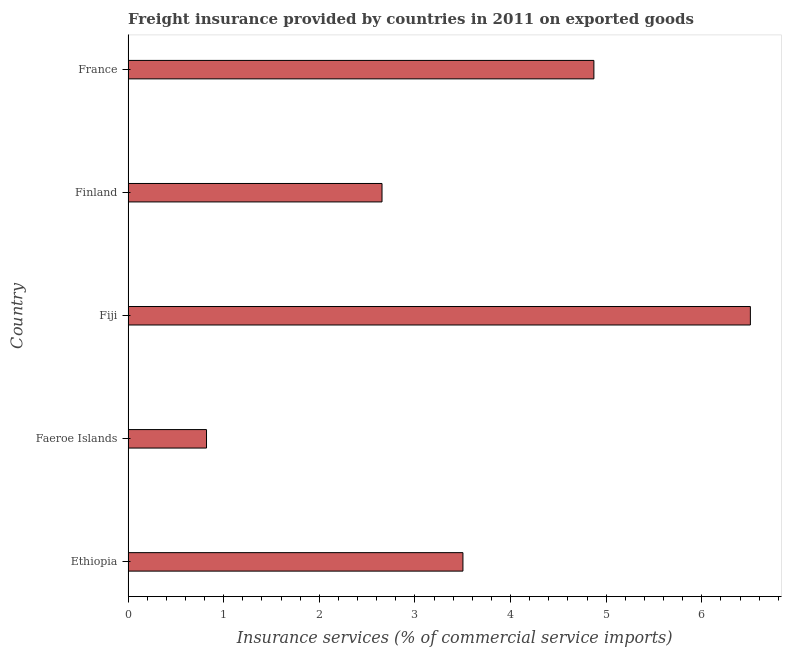Does the graph contain grids?
Your response must be concise. No. What is the title of the graph?
Make the answer very short. Freight insurance provided by countries in 2011 on exported goods . What is the label or title of the X-axis?
Offer a very short reply. Insurance services (% of commercial service imports). What is the label or title of the Y-axis?
Your response must be concise. Country. What is the freight insurance in Faeroe Islands?
Your answer should be very brief. 0.82. Across all countries, what is the maximum freight insurance?
Provide a short and direct response. 6.51. Across all countries, what is the minimum freight insurance?
Your response must be concise. 0.82. In which country was the freight insurance maximum?
Keep it short and to the point. Fiji. In which country was the freight insurance minimum?
Your answer should be compact. Faeroe Islands. What is the sum of the freight insurance?
Make the answer very short. 18.36. What is the difference between the freight insurance in Faeroe Islands and Fiji?
Provide a short and direct response. -5.69. What is the average freight insurance per country?
Offer a very short reply. 3.67. What is the median freight insurance?
Your answer should be very brief. 3.5. What is the ratio of the freight insurance in Finland to that in France?
Your answer should be very brief. 0.55. Is the freight insurance in Ethiopia less than that in Fiji?
Your answer should be compact. Yes. Is the difference between the freight insurance in Fiji and Finland greater than the difference between any two countries?
Give a very brief answer. No. What is the difference between the highest and the second highest freight insurance?
Your response must be concise. 1.64. Is the sum of the freight insurance in Finland and France greater than the maximum freight insurance across all countries?
Give a very brief answer. Yes. What is the difference between the highest and the lowest freight insurance?
Ensure brevity in your answer.  5.69. Are all the bars in the graph horizontal?
Offer a terse response. Yes. What is the difference between two consecutive major ticks on the X-axis?
Offer a very short reply. 1. What is the Insurance services (% of commercial service imports) in Ethiopia?
Provide a short and direct response. 3.5. What is the Insurance services (% of commercial service imports) of Faeroe Islands?
Ensure brevity in your answer.  0.82. What is the Insurance services (% of commercial service imports) in Fiji?
Offer a terse response. 6.51. What is the Insurance services (% of commercial service imports) in Finland?
Make the answer very short. 2.66. What is the Insurance services (% of commercial service imports) of France?
Your answer should be very brief. 4.87. What is the difference between the Insurance services (% of commercial service imports) in Ethiopia and Faeroe Islands?
Your response must be concise. 2.68. What is the difference between the Insurance services (% of commercial service imports) in Ethiopia and Fiji?
Your response must be concise. -3.01. What is the difference between the Insurance services (% of commercial service imports) in Ethiopia and Finland?
Offer a terse response. 0.85. What is the difference between the Insurance services (% of commercial service imports) in Ethiopia and France?
Your response must be concise. -1.37. What is the difference between the Insurance services (% of commercial service imports) in Faeroe Islands and Fiji?
Give a very brief answer. -5.69. What is the difference between the Insurance services (% of commercial service imports) in Faeroe Islands and Finland?
Give a very brief answer. -1.84. What is the difference between the Insurance services (% of commercial service imports) in Faeroe Islands and France?
Ensure brevity in your answer.  -4.05. What is the difference between the Insurance services (% of commercial service imports) in Fiji and Finland?
Keep it short and to the point. 3.85. What is the difference between the Insurance services (% of commercial service imports) in Fiji and France?
Your answer should be compact. 1.64. What is the difference between the Insurance services (% of commercial service imports) in Finland and France?
Ensure brevity in your answer.  -2.22. What is the ratio of the Insurance services (% of commercial service imports) in Ethiopia to that in Faeroe Islands?
Your answer should be compact. 4.27. What is the ratio of the Insurance services (% of commercial service imports) in Ethiopia to that in Fiji?
Make the answer very short. 0.54. What is the ratio of the Insurance services (% of commercial service imports) in Ethiopia to that in Finland?
Make the answer very short. 1.32. What is the ratio of the Insurance services (% of commercial service imports) in Ethiopia to that in France?
Your answer should be compact. 0.72. What is the ratio of the Insurance services (% of commercial service imports) in Faeroe Islands to that in Fiji?
Your response must be concise. 0.13. What is the ratio of the Insurance services (% of commercial service imports) in Faeroe Islands to that in Finland?
Give a very brief answer. 0.31. What is the ratio of the Insurance services (% of commercial service imports) in Faeroe Islands to that in France?
Your answer should be compact. 0.17. What is the ratio of the Insurance services (% of commercial service imports) in Fiji to that in Finland?
Your answer should be very brief. 2.45. What is the ratio of the Insurance services (% of commercial service imports) in Fiji to that in France?
Your answer should be compact. 1.34. What is the ratio of the Insurance services (% of commercial service imports) in Finland to that in France?
Offer a very short reply. 0.55. 